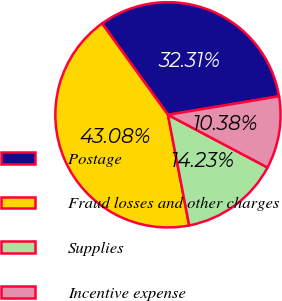Convert chart. <chart><loc_0><loc_0><loc_500><loc_500><pie_chart><fcel>Postage<fcel>Fraud losses and other charges<fcel>Supplies<fcel>Incentive expense<nl><fcel>32.31%<fcel>43.08%<fcel>14.23%<fcel>10.38%<nl></chart> 